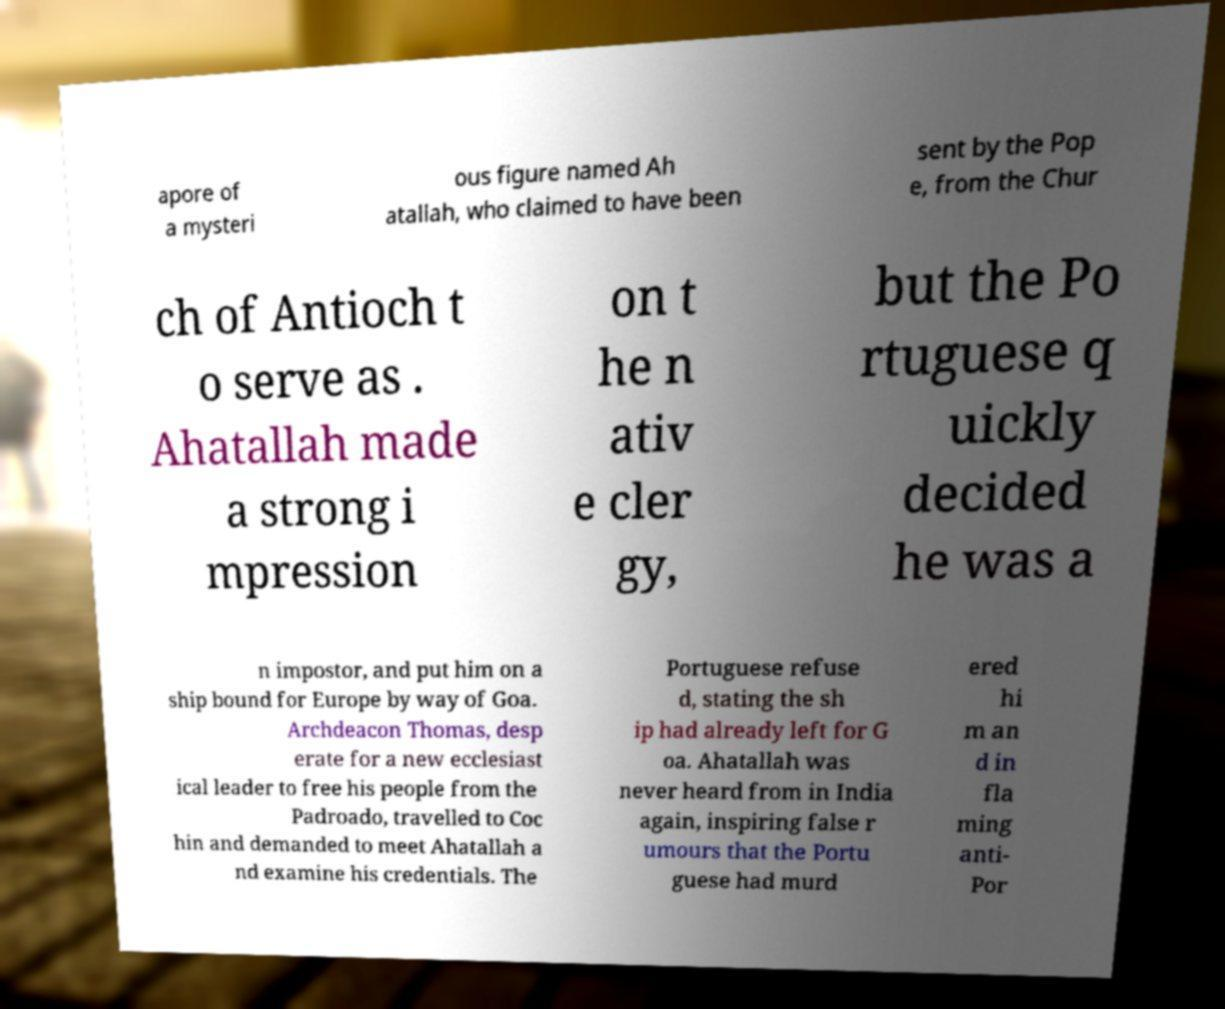Could you extract and type out the text from this image? apore of a mysteri ous figure named Ah atallah, who claimed to have been sent by the Pop e, from the Chur ch of Antioch t o serve as . Ahatallah made a strong i mpression on t he n ativ e cler gy, but the Po rtuguese q uickly decided he was a n impostor, and put him on a ship bound for Europe by way of Goa. Archdeacon Thomas, desp erate for a new ecclesiast ical leader to free his people from the Padroado, travelled to Coc hin and demanded to meet Ahatallah a nd examine his credentials. The Portuguese refuse d, stating the sh ip had already left for G oa. Ahatallah was never heard from in India again, inspiring false r umours that the Portu guese had murd ered hi m an d in fla ming anti- Por 